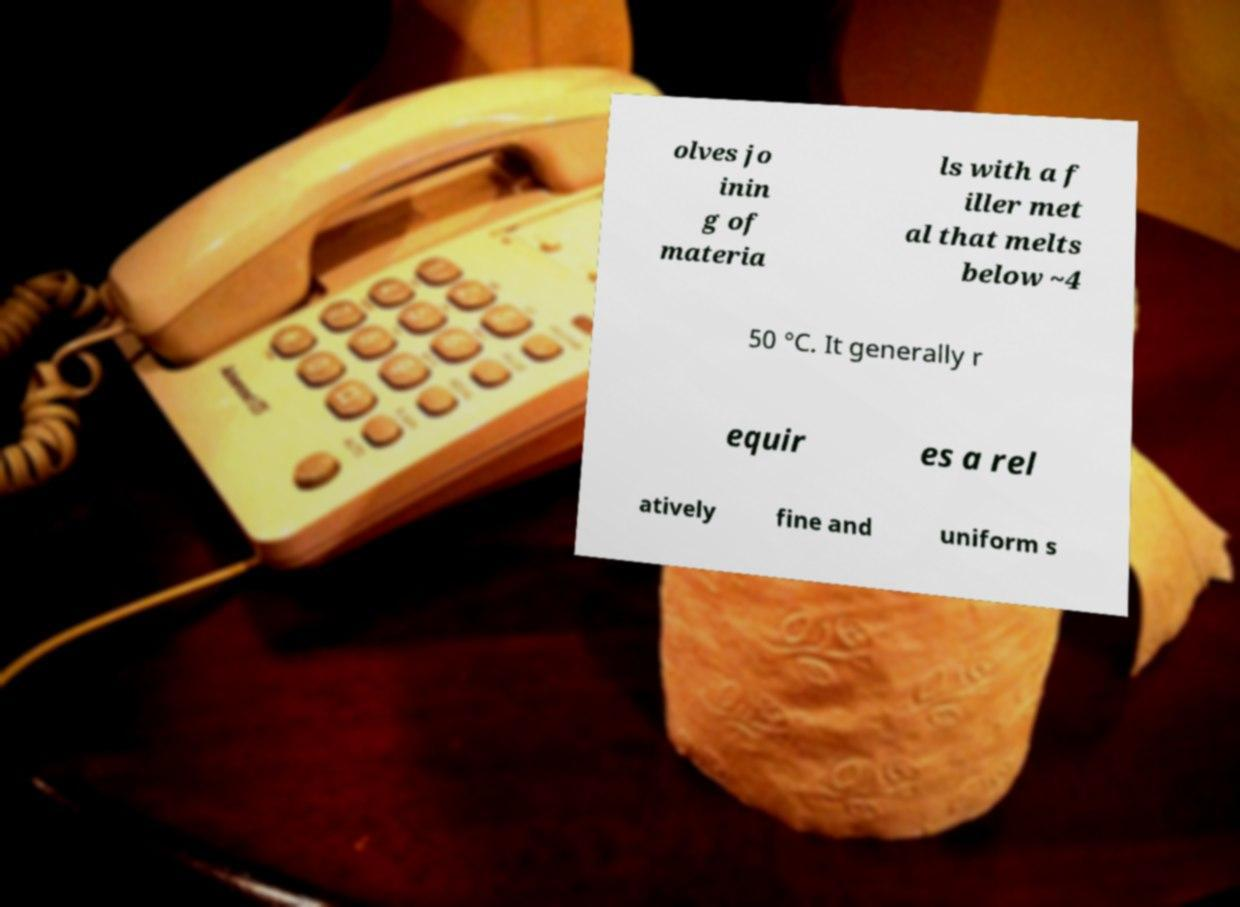Could you extract and type out the text from this image? olves jo inin g of materia ls with a f iller met al that melts below ~4 50 °C. It generally r equir es a rel atively fine and uniform s 